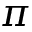<formula> <loc_0><loc_0><loc_500><loc_500>\pi</formula> 